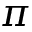<formula> <loc_0><loc_0><loc_500><loc_500>\pi</formula> 